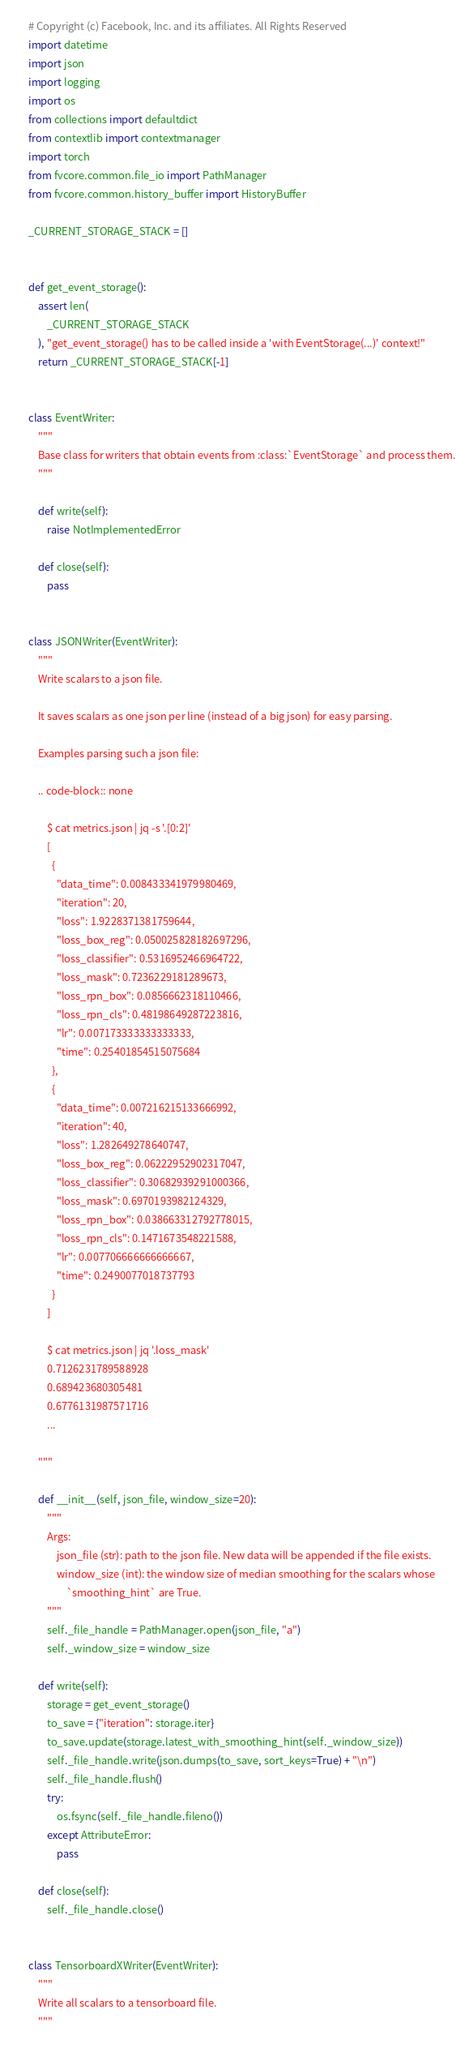<code> <loc_0><loc_0><loc_500><loc_500><_Python_># Copyright (c) Facebook, Inc. and its affiliates. All Rights Reserved
import datetime
import json
import logging
import os
from collections import defaultdict
from contextlib import contextmanager
import torch
from fvcore.common.file_io import PathManager
from fvcore.common.history_buffer import HistoryBuffer

_CURRENT_STORAGE_STACK = []


def get_event_storage():
    assert len(
        _CURRENT_STORAGE_STACK
    ), "get_event_storage() has to be called inside a 'with EventStorage(...)' context!"
    return _CURRENT_STORAGE_STACK[-1]


class EventWriter:
    """
    Base class for writers that obtain events from :class:`EventStorage` and process them.
    """

    def write(self):
        raise NotImplementedError

    def close(self):
        pass


class JSONWriter(EventWriter):
    """
    Write scalars to a json file.

    It saves scalars as one json per line (instead of a big json) for easy parsing.

    Examples parsing such a json file:

    .. code-block:: none

        $ cat metrics.json | jq -s '.[0:2]'
        [
          {
            "data_time": 0.008433341979980469,
            "iteration": 20,
            "loss": 1.9228371381759644,
            "loss_box_reg": 0.050025828182697296,
            "loss_classifier": 0.5316952466964722,
            "loss_mask": 0.7236229181289673,
            "loss_rpn_box": 0.0856662318110466,
            "loss_rpn_cls": 0.48198649287223816,
            "lr": 0.007173333333333333,
            "time": 0.25401854515075684
          },
          {
            "data_time": 0.007216215133666992,
            "iteration": 40,
            "loss": 1.282649278640747,
            "loss_box_reg": 0.06222952902317047,
            "loss_classifier": 0.30682939291000366,
            "loss_mask": 0.6970193982124329,
            "loss_rpn_box": 0.038663312792778015,
            "loss_rpn_cls": 0.1471673548221588,
            "lr": 0.007706666666666667,
            "time": 0.2490077018737793
          }
        ]

        $ cat metrics.json | jq '.loss_mask'
        0.7126231789588928
        0.689423680305481
        0.6776131987571716
        ...

    """

    def __init__(self, json_file, window_size=20):
        """
        Args:
            json_file (str): path to the json file. New data will be appended if the file exists.
            window_size (int): the window size of median smoothing for the scalars whose
                `smoothing_hint` are True.
        """
        self._file_handle = PathManager.open(json_file, "a")
        self._window_size = window_size

    def write(self):
        storage = get_event_storage()
        to_save = {"iteration": storage.iter}
        to_save.update(storage.latest_with_smoothing_hint(self._window_size))
        self._file_handle.write(json.dumps(to_save, sort_keys=True) + "\n")
        self._file_handle.flush()
        try:
            os.fsync(self._file_handle.fileno())
        except AttributeError:
            pass

    def close(self):
        self._file_handle.close()


class TensorboardXWriter(EventWriter):
    """
    Write all scalars to a tensorboard file.
    """
</code> 